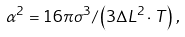<formula> <loc_0><loc_0><loc_500><loc_500>\alpha ^ { 2 } = 1 6 \pi \sigma ^ { 3 } / \left ( 3 \Delta L ^ { 2 } \cdot T \right ) \, ,</formula> 